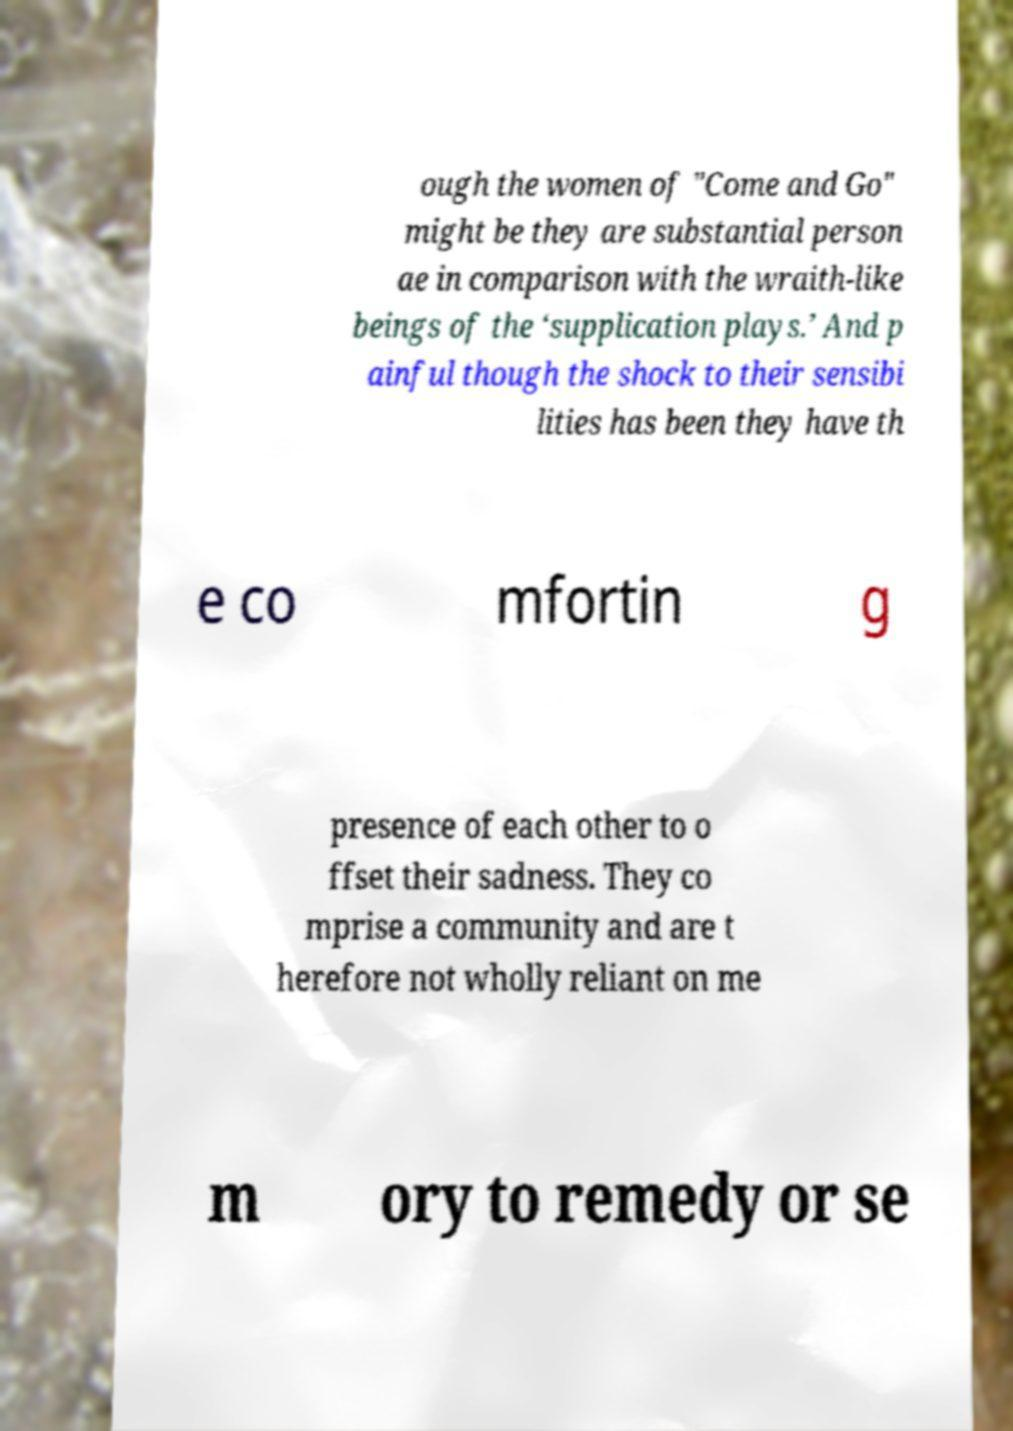Please identify and transcribe the text found in this image. ough the women of "Come and Go" might be they are substantial person ae in comparison with the wraith-like beings of the ‘supplication plays.’ And p ainful though the shock to their sensibi lities has been they have th e co mfortin g presence of each other to o ffset their sadness. They co mprise a community and are t herefore not wholly reliant on me m ory to remedy or se 